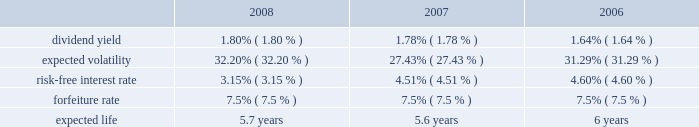N o t e s t o c o n s o l i d a t e d f i n a n c i a l s t a t e m e n t s ( continued ) ace limited and subsidiaries share-based compensation expense for stock options and shares issued under the employee stock purchase plan ( espp ) amounted to $ 24 million ( $ 22 million after tax or $ 0.07 per basic and diluted share ) , $ 23 million ( $ 21 million after tax or $ 0.06 per basic and diluted share ) , and $ 20 million ( $ 18 million after tax or $ 0.05 per basic and diluted share ) for the years ended december 31 , 2008 , 2007 , and 2006 , respectively .
For the years ended december 31 , 2008 , 2007 and 2006 , the expense for the restricted stock was $ 101 million ( $ 71 million after tax ) , $ 77 million ( $ 57 million after tax ) , and $ 65 million ( $ 49 million after tax ) , respectively .
During 2004 , the company established the ace limited 2004 long-term incentive plan ( the 2004 ltip ) .
Once the 2004 ltip was approved by shareholders , it became effective february 25 , 2004 .
It will continue in effect until terminated by the board .
This plan replaced the ace limited 1995 long-term incentive plan , the ace limited 1995 outside directors plan , the ace limited 1998 long-term incentive plan , and the ace limited 1999 replacement long-term incentive plan ( the prior plans ) except as to outstanding awards .
During the company 2019s 2008 annual general meeting , shareholders voted to increase the number of common shares authorized to be issued under the 2004 ltip from 15000000 common shares to 19000000 common shares .
Accordingly , under the 2004 ltip , a total of 19000000 common shares of the company are authorized to be issued pursuant to awards made as stock options , stock appreciation rights , performance shares , performance units , restricted stock , and restricted stock units .
The maximum number of shares that may be delivered to participants and their beneficiaries under the 2004 ltip shall be equal to the sum of : ( i ) 19000000 shares ; and ( ii ) any shares that are represented by awards granted under the prior plans that are forfeited , expired , or are canceled after the effective date of the 2004 ltip , without delivery of shares or which result in the forfeiture of the shares back to the company to the extent that such shares would have been added back to the reserve under the terms of the applicable prior plan .
As of december 31 , 2008 , a total of 10591090 shares remain available for future issuance under this plan .
Under the 2004 ltip , 3000000 common shares are authorized to be issued under the espp .
As of december 31 , 2008 , a total of 989812 common shares remain available for issuance under the espp .
Stock options the company 2019s 2004 ltip provides for grants of both incentive and non-qualified stock options principally at an option price per share of 100 percent of the fair value of the company 2019s common shares on the date of grant .
Stock options are generally granted with a 3-year vesting period and a 10-year term .
The stock options vest in equal annual installments over the respective vesting period , which is also the requisite service period .
Included in the company 2019s share-based compensation expense in the year ended december 31 , 2008 , is the cost related to the unvested portion of the 2005-2008 stock option grants .
The fair value of the stock options was estimated on the date of grant using the black-scholes option-pricing model that uses the assumptions noted in the table .
The risk-free inter- est rate is based on the u.s .
Treasury yield curve in effect at the time of grant .
The expected life ( estimated period of time from grant to exercise date ) was estimated using the historical exercise behavior of employees .
Expected volatility was calculated as a blend of ( a ) historical volatility based on daily closing prices over a period equal to the expected life assumption , ( b ) long- term historical volatility based on daily closing prices over the period from ace 2019s initial public trading date through the most recent quarter , and ( c ) implied volatility derived from ace 2019s publicly traded options .
The fair value of the options issued is estimated on the date of grant using the black-scholes option-pricing model , with the following weighted-average assumptions used for grants for the years indicated: .

What is the percentage change in risk-free interest rate from 2007 to 2008? 
Computations: ((3.15 - 4.51) / 4.51)
Answer: -0.30155. 